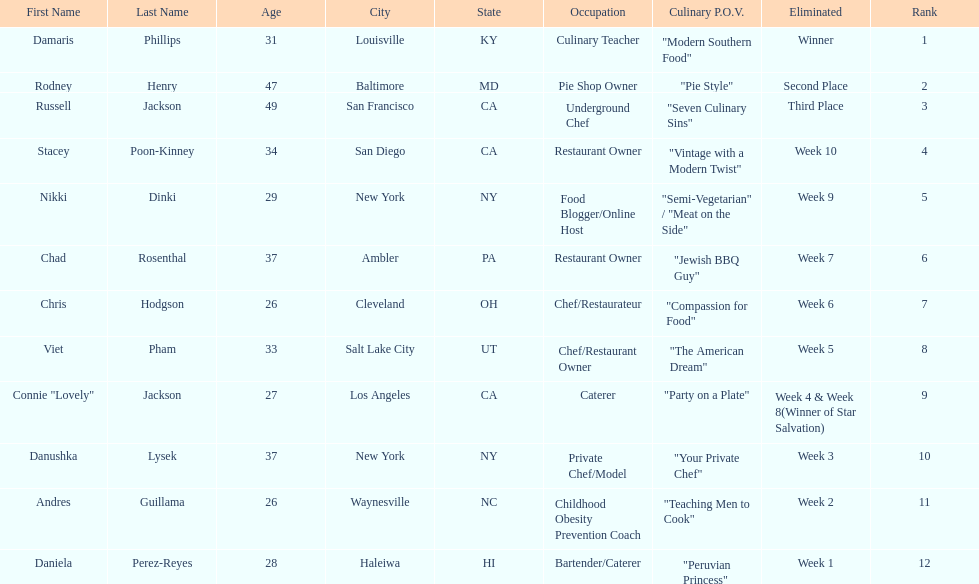Who was the top chef? Damaris Phillips. 